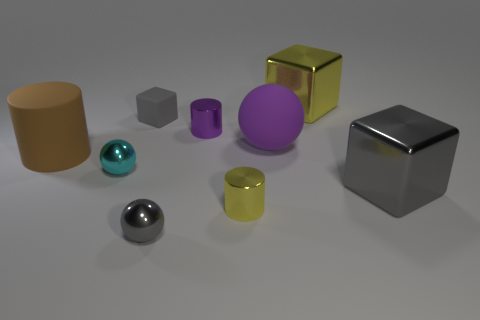There is a yellow metal object that is in front of the large brown matte cylinder; does it have the same size as the yellow metallic thing behind the large cylinder?
Your answer should be very brief. No. Are there any cyan objects that have the same size as the purple metallic cylinder?
Provide a succinct answer. Yes. What number of large objects are to the left of the big thing that is behind the purple matte thing?
Ensure brevity in your answer.  2. What material is the yellow cylinder?
Your answer should be very brief. Metal. There is a tiny gray sphere; what number of small gray blocks are on the left side of it?
Keep it short and to the point. 1. How many cubes are the same color as the big matte cylinder?
Offer a terse response. 0. Is the number of matte spheres greater than the number of big green metal things?
Your answer should be very brief. Yes. How big is the object that is to the right of the purple cylinder and to the left of the purple sphere?
Your response must be concise. Small. Does the purple object that is to the right of the small yellow cylinder have the same material as the tiny cylinder in front of the small purple thing?
Ensure brevity in your answer.  No. What shape is the purple matte object that is the same size as the matte cylinder?
Keep it short and to the point. Sphere. 